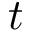<formula> <loc_0><loc_0><loc_500><loc_500>t</formula> 